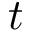<formula> <loc_0><loc_0><loc_500><loc_500>t</formula> 